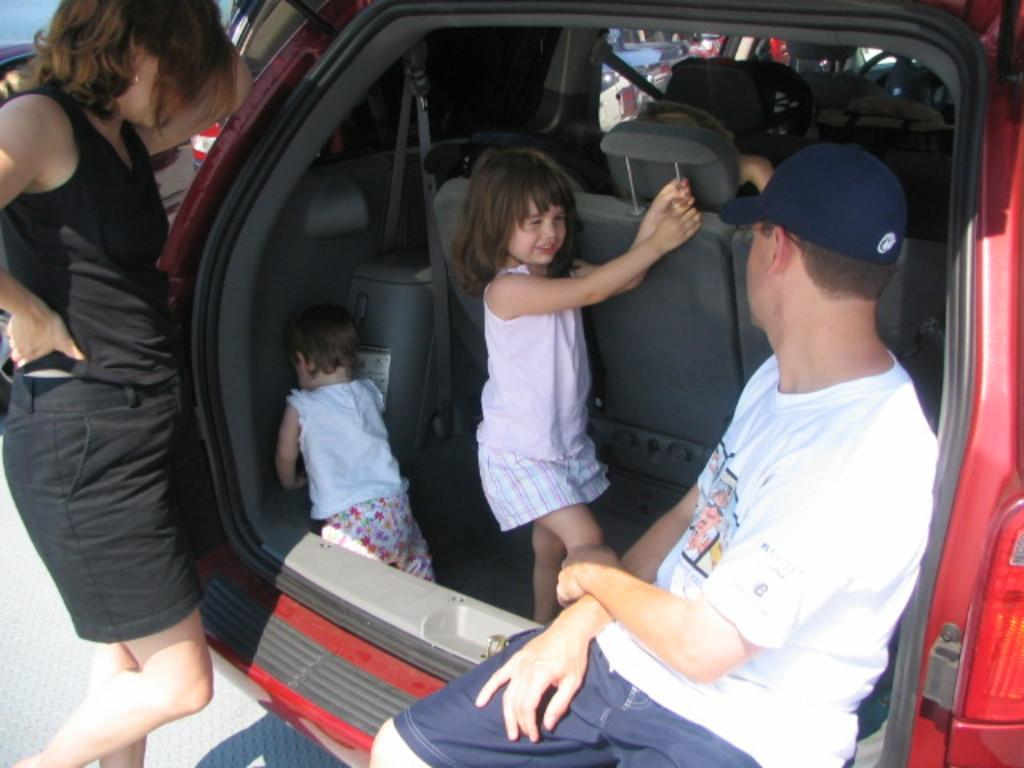What is the main subject of the image? The main subject of the image is a car. Are there any people in the image? Yes, there are two children inside the car, a man sitting near the car, and a woman standing near the car. What type of line can be seen connecting the car to the cheese in the image? There is no cheese present in the image, and therefore no line connecting it to the car. 